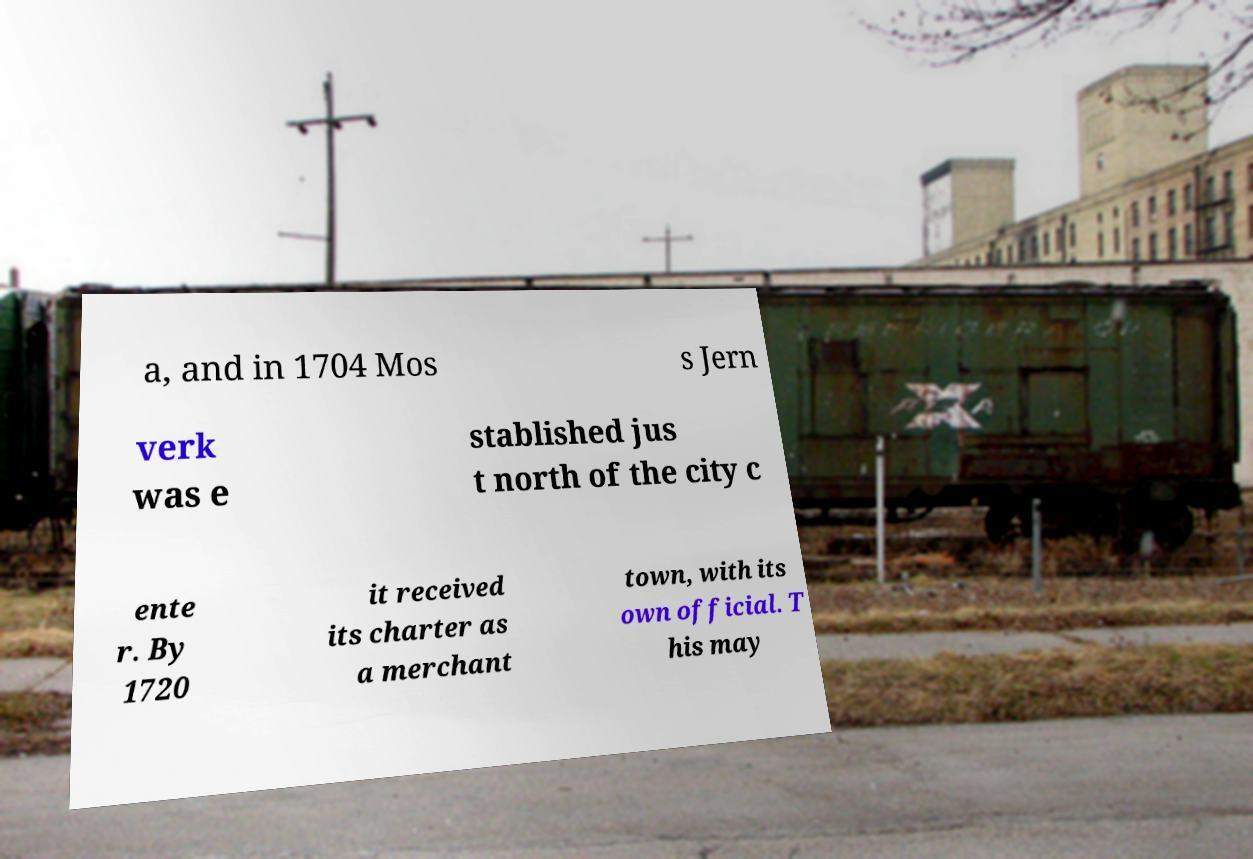I need the written content from this picture converted into text. Can you do that? a, and in 1704 Mos s Jern verk was e stablished jus t north of the city c ente r. By 1720 it received its charter as a merchant town, with its own official. T his may 